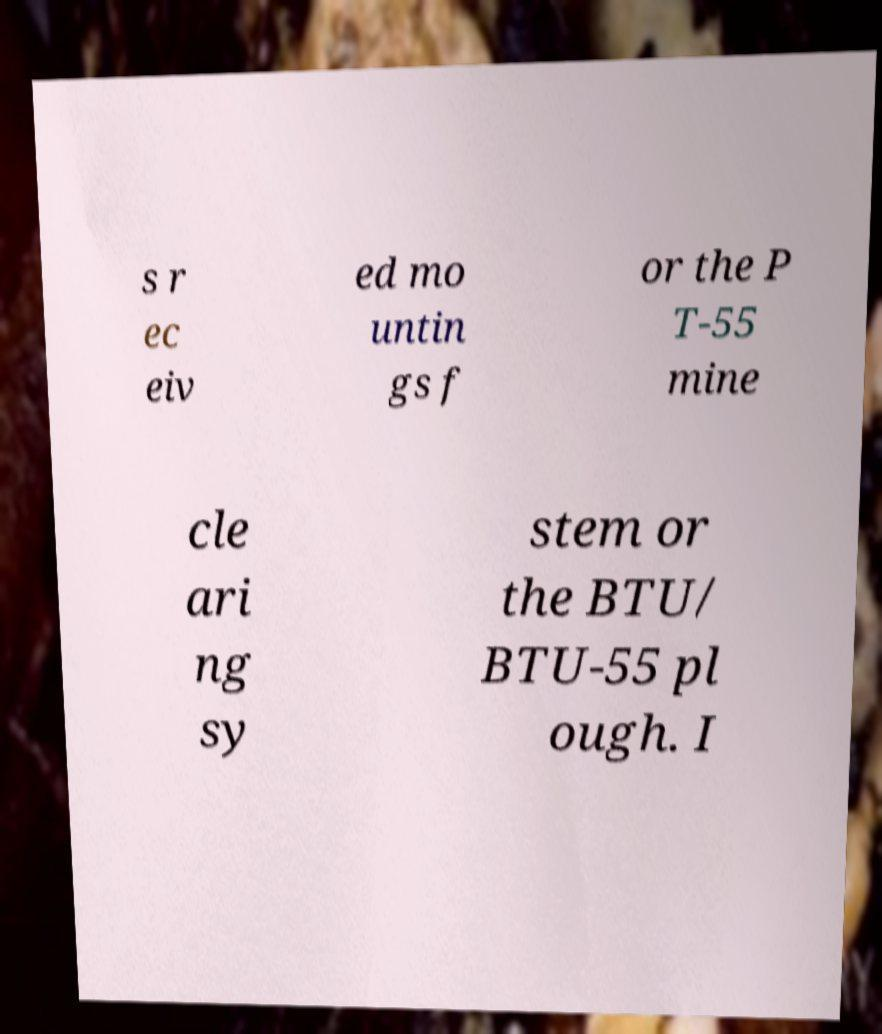I need the written content from this picture converted into text. Can you do that? s r ec eiv ed mo untin gs f or the P T-55 mine cle ari ng sy stem or the BTU/ BTU-55 pl ough. I 